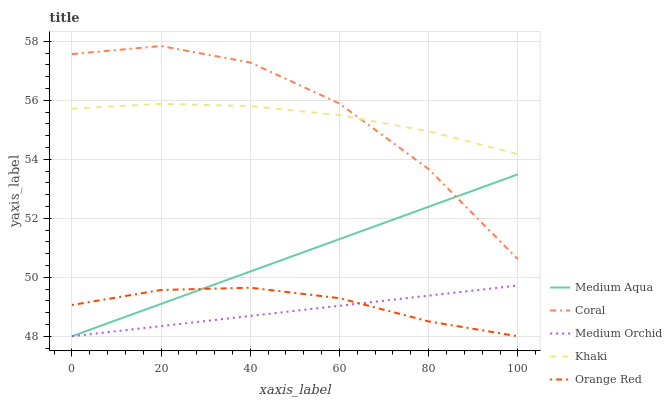Does Medium Orchid have the minimum area under the curve?
Answer yes or no. Yes. Does Coral have the maximum area under the curve?
Answer yes or no. Yes. Does Medium Aqua have the minimum area under the curve?
Answer yes or no. No. Does Medium Aqua have the maximum area under the curve?
Answer yes or no. No. Is Medium Aqua the smoothest?
Answer yes or no. Yes. Is Coral the roughest?
Answer yes or no. Yes. Is Medium Orchid the smoothest?
Answer yes or no. No. Is Medium Orchid the roughest?
Answer yes or no. No. Does Medium Orchid have the lowest value?
Answer yes or no. Yes. Does Khaki have the lowest value?
Answer yes or no. No. Does Coral have the highest value?
Answer yes or no. Yes. Does Medium Orchid have the highest value?
Answer yes or no. No. Is Medium Orchid less than Coral?
Answer yes or no. Yes. Is Khaki greater than Medium Aqua?
Answer yes or no. Yes. Does Medium Aqua intersect Medium Orchid?
Answer yes or no. Yes. Is Medium Aqua less than Medium Orchid?
Answer yes or no. No. Is Medium Aqua greater than Medium Orchid?
Answer yes or no. No. Does Medium Orchid intersect Coral?
Answer yes or no. No. 